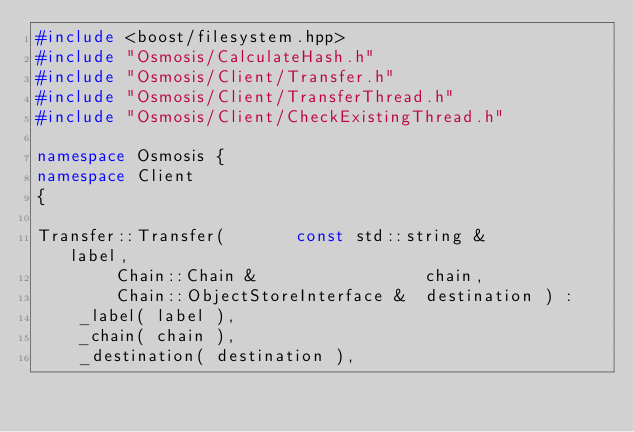Convert code to text. <code><loc_0><loc_0><loc_500><loc_500><_C++_>#include <boost/filesystem.hpp>
#include "Osmosis/CalculateHash.h"
#include "Osmosis/Client/Transfer.h"
#include "Osmosis/Client/TransferThread.h"
#include "Osmosis/Client/CheckExistingThread.h"

namespace Osmosis {
namespace Client
{

Transfer::Transfer(       const std::string &            label,
		Chain::Chain &                 chain,
		Chain::ObjectStoreInterface &  destination ) :
	_label( label ),
	_chain( chain ),
	_destination( destination ),</code> 